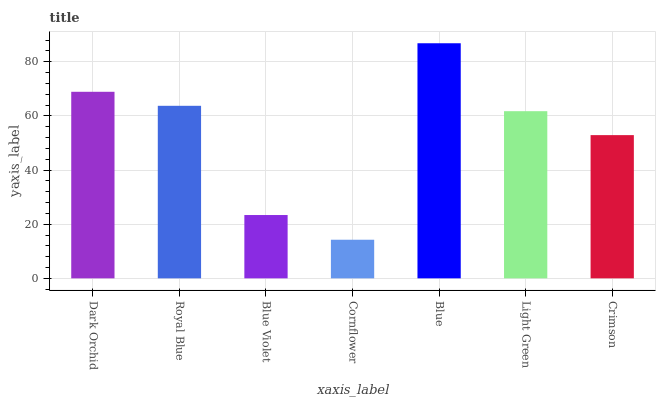Is Cornflower the minimum?
Answer yes or no. Yes. Is Blue the maximum?
Answer yes or no. Yes. Is Royal Blue the minimum?
Answer yes or no. No. Is Royal Blue the maximum?
Answer yes or no. No. Is Dark Orchid greater than Royal Blue?
Answer yes or no. Yes. Is Royal Blue less than Dark Orchid?
Answer yes or no. Yes. Is Royal Blue greater than Dark Orchid?
Answer yes or no. No. Is Dark Orchid less than Royal Blue?
Answer yes or no. No. Is Light Green the high median?
Answer yes or no. Yes. Is Light Green the low median?
Answer yes or no. Yes. Is Crimson the high median?
Answer yes or no. No. Is Blue the low median?
Answer yes or no. No. 